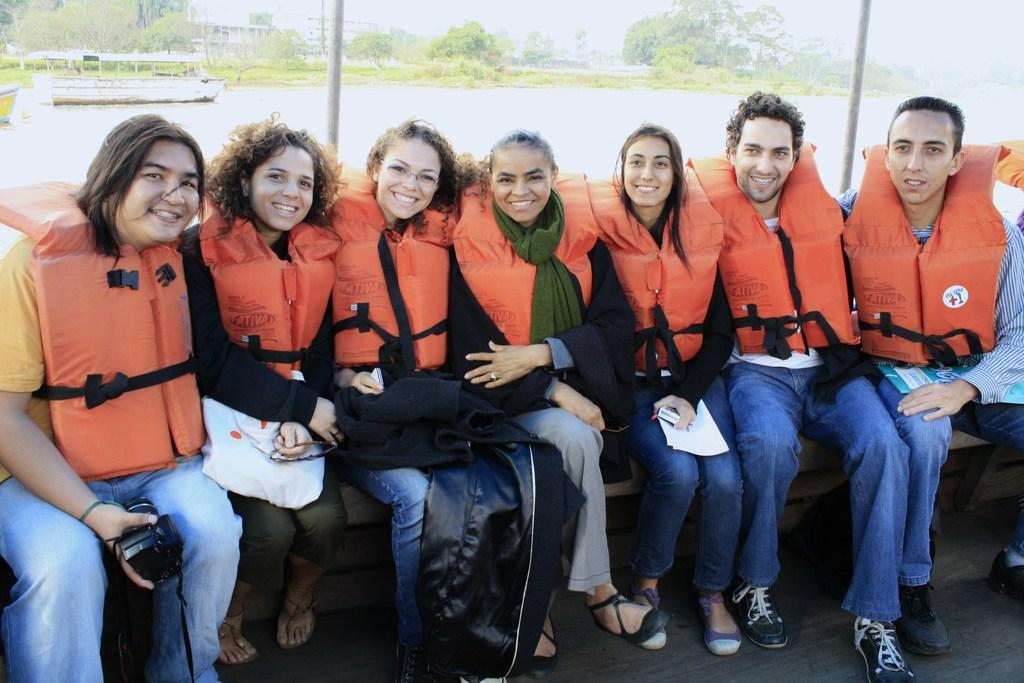What are the people in the image doing with the objects they are holding? The facts do not specify what the objects are or what the people are doing with them. Where are the people sitting in the image? The people are sitting on a bench in the image. What type of vegetation can be seen in the image? There are trees visible in the image. What architectural features can be seen in the image? There are poles and a building visible in the image. How does the blade feel about being in the image? There is no blade present in the image, so it cannot have any feelings about being in the image. 